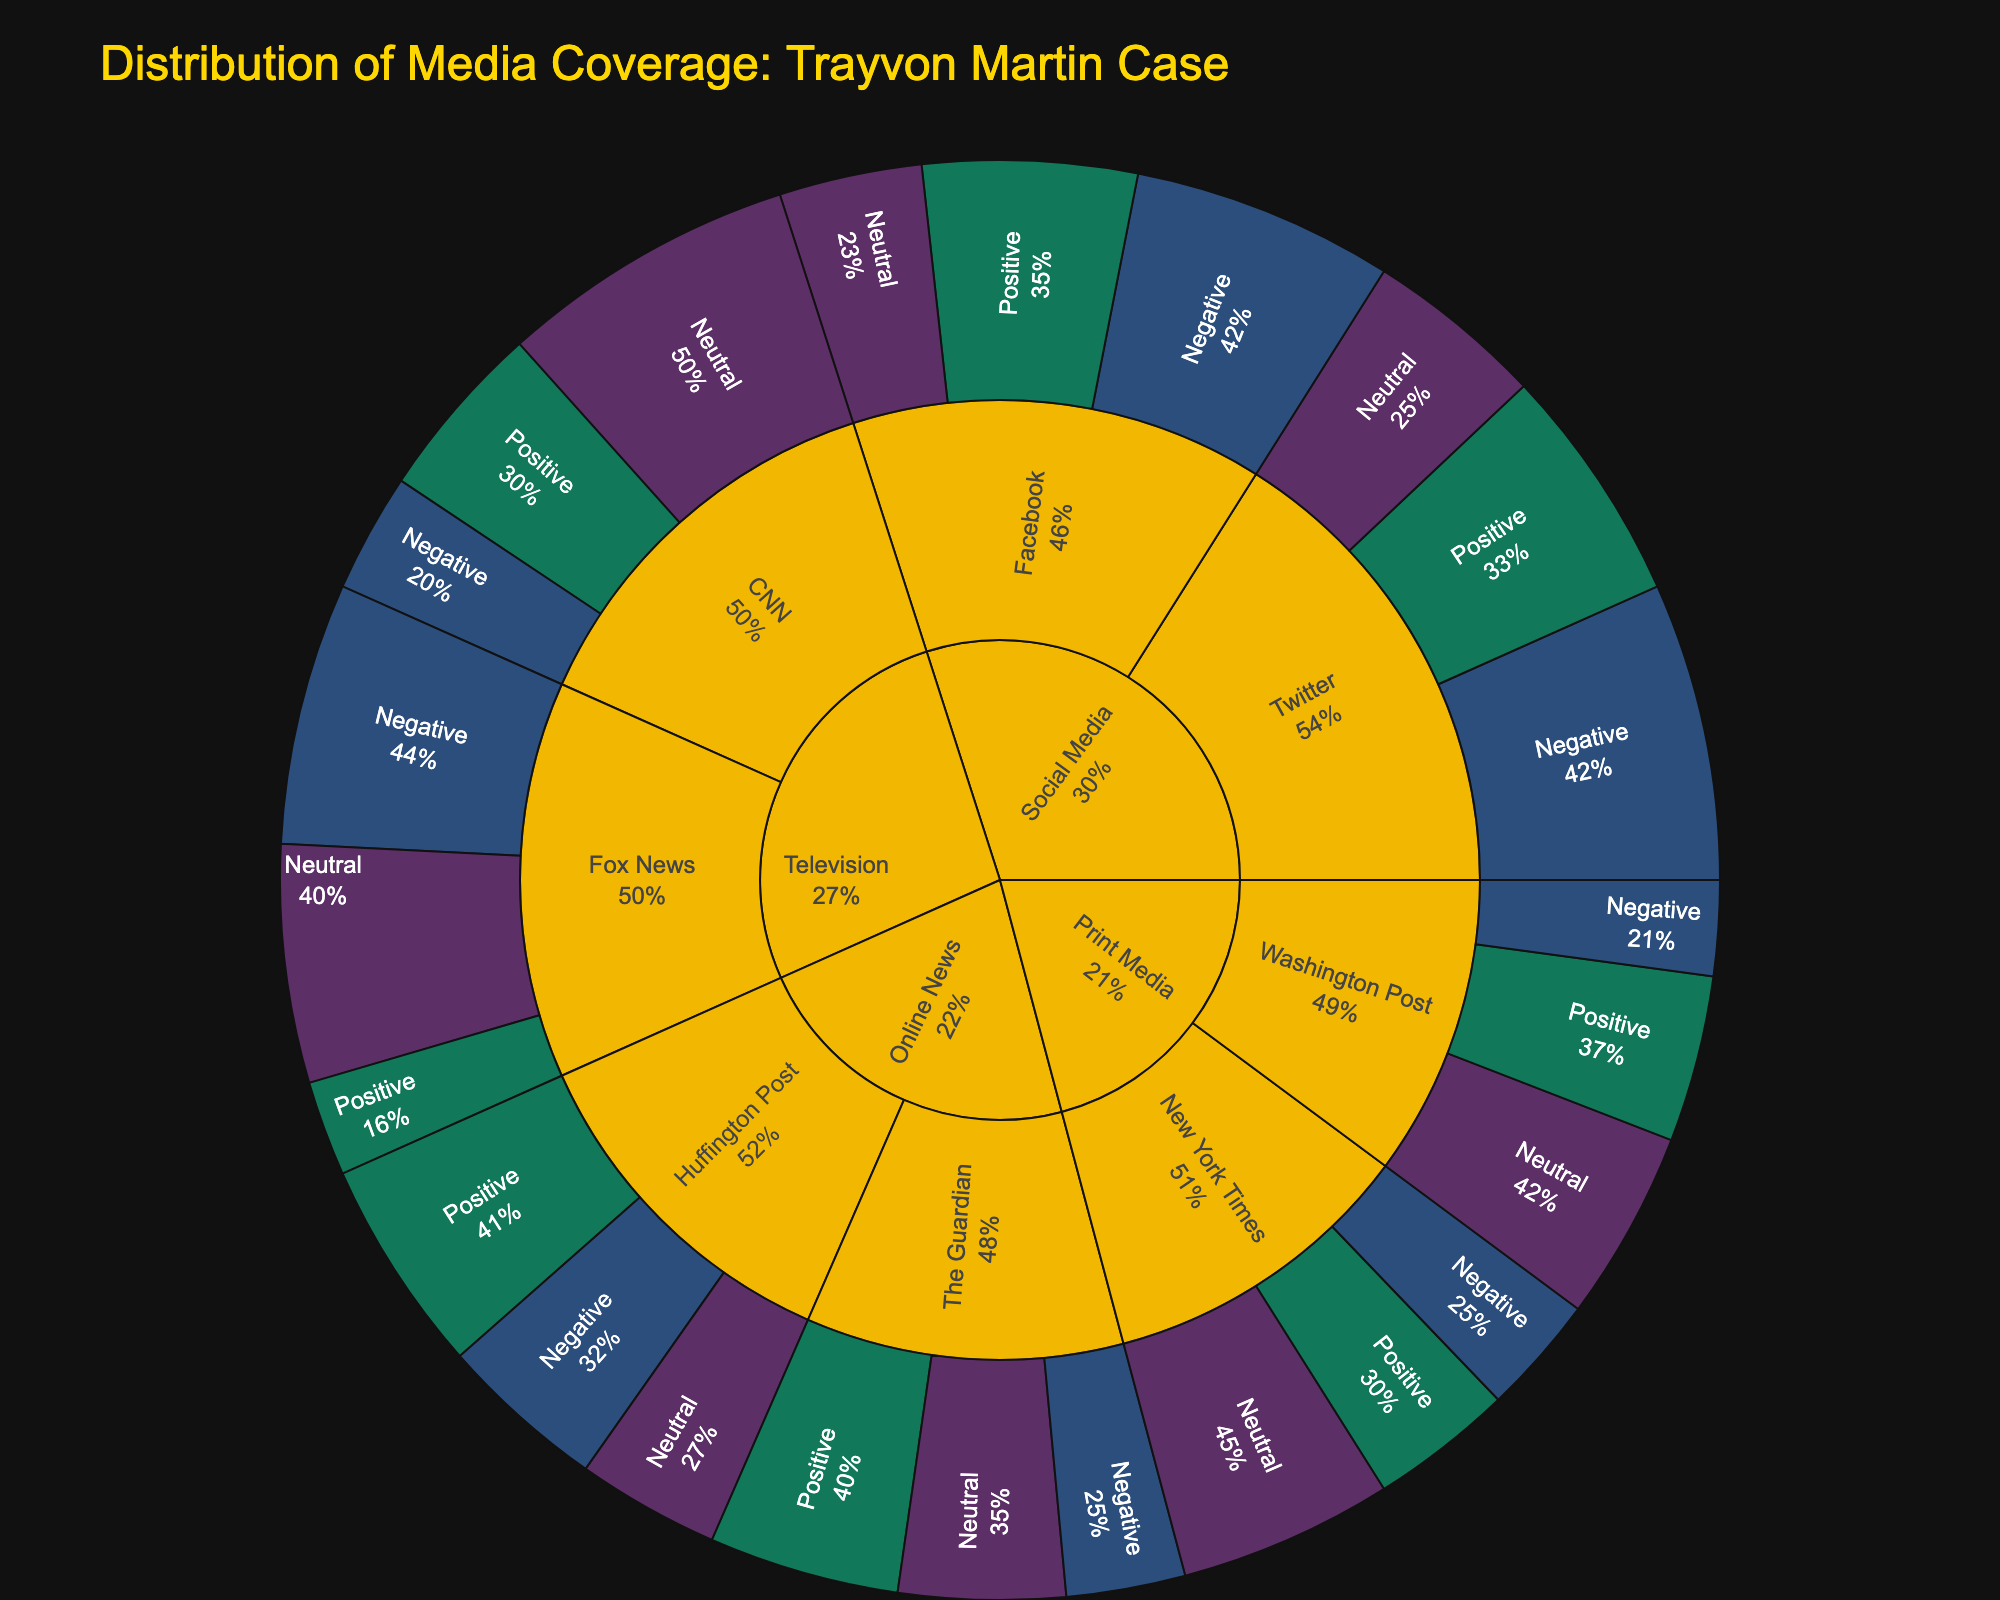How many percentage points of media coverage on CNN were neutral? By finding the percentage associated with CNN and the Neutral category, we see it is 25%.
Answer: 25% Which platform had the highest percentage of negative sentiment in the coverage? By looking at the outer ring labeled Negative in the Sunburst plot, Twitter in Social Media had the highest negative percentage, which was 25%.
Answer: Twitter What's the total percentage of positive sentiment across all platforms? Summing the percentages for the Positive category across all platforms: CNN (15) + Fox News (8) + New York Times (12) + Washington Post (14) + Twitter (20) + Facebook (18) + The Guardian (16) + Huffington Post (18) = 121%.
Answer: 121% Which had a higher percentage of negative coverage, New York Times or Washington Post? Comparing the percentages in the Print Media category under Negative, New York Times had 10%, and Washington Post had 8%.
Answer: New York Times In the Television category, what is the combined percentage of positive and neutral sentiment for Fox News? Adding the percentages for Positive and Neutral under Fox News: 8% + 20% = 28%.
Answer: 28% Is there a platform with equal percentages of neutral and negative sentiment? If yes, which one? By checking the Neutral and Negative subcategories within each platform, Huffington Post has both Neutral and Negative at 12%.
Answer: Huffington Post Which platform in Print Media has a higher percentage of positive sentiment? Comparing the Positive percentages for New York Times (12%) and Washington Post (14%), Washington Post has a higher percentage.
Answer: Washington Post What is the difference in the percentage of negative coverage between Twitter and Facebook? Subtracting Facebook's Negative percentage from Twitter's: 25% (Twitter) - 22% (Facebook) = 3%.
Answer: 3% Across all platforms, which sentiment had the lowest total percentage? Summing the total percentages for each sentiment: Positive (121%), Neutral (132%), and Negative (121%). The sentiments Positive and Negative are equal and the lowest.
Answer: Positive, Negative In Online News, which source had the higher percentage of neutral sentiment? Comparing the Neutral percentages for The Guardian (14%) and Huffington Post (12%), The Guardian has a higher percentage.
Answer: The Guardian 